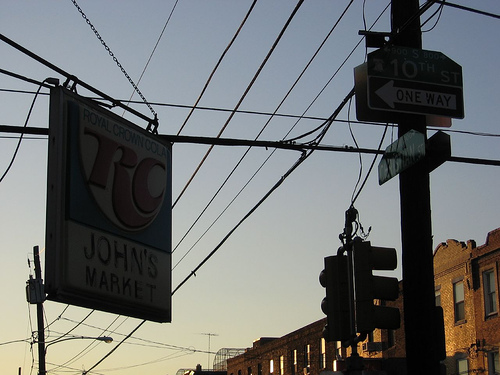Read all the text in this image. CROWN COLA RC ONE WAY ST 10 MARKET JOHN'S 